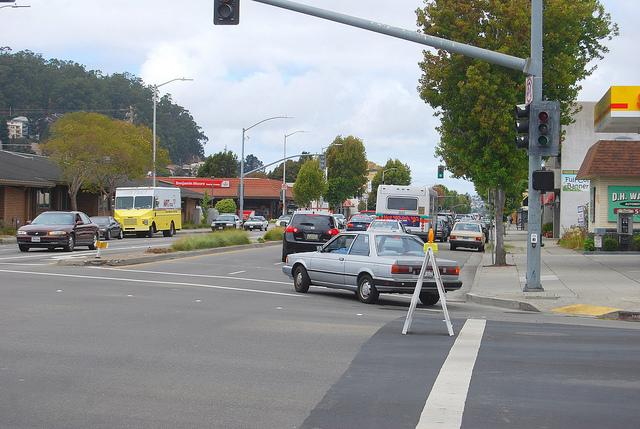What type of traffic does this road have? automobile 